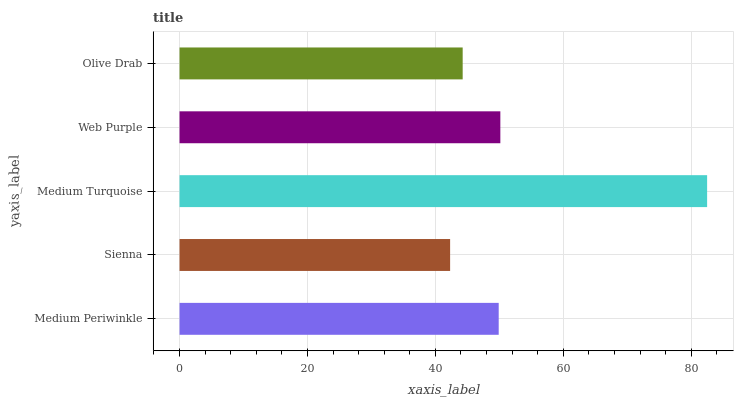Is Sienna the minimum?
Answer yes or no. Yes. Is Medium Turquoise the maximum?
Answer yes or no. Yes. Is Medium Turquoise the minimum?
Answer yes or no. No. Is Sienna the maximum?
Answer yes or no. No. Is Medium Turquoise greater than Sienna?
Answer yes or no. Yes. Is Sienna less than Medium Turquoise?
Answer yes or no. Yes. Is Sienna greater than Medium Turquoise?
Answer yes or no. No. Is Medium Turquoise less than Sienna?
Answer yes or no. No. Is Medium Periwinkle the high median?
Answer yes or no. Yes. Is Medium Periwinkle the low median?
Answer yes or no. Yes. Is Web Purple the high median?
Answer yes or no. No. Is Sienna the low median?
Answer yes or no. No. 